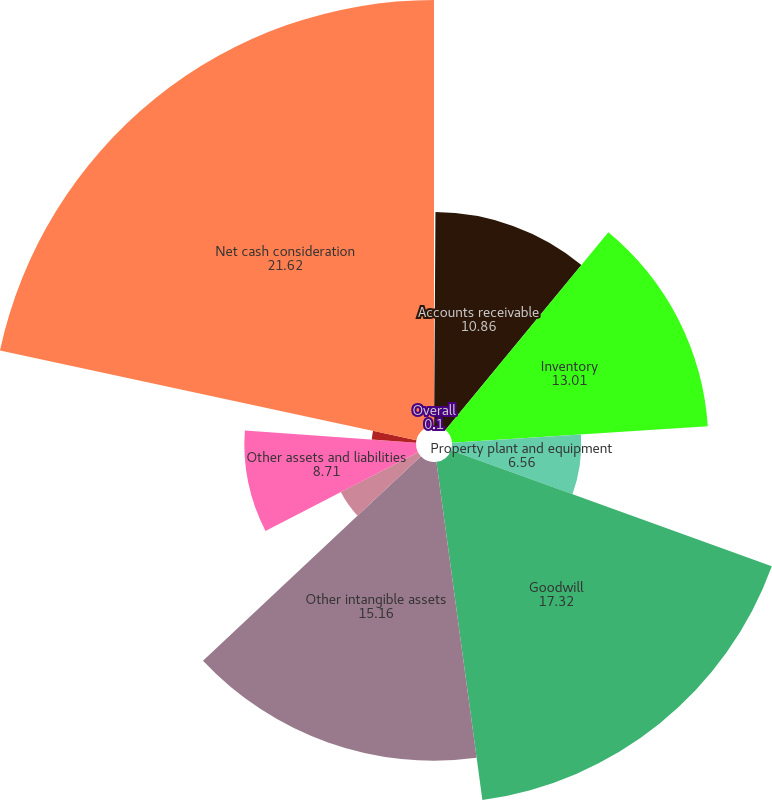Convert chart to OTSL. <chart><loc_0><loc_0><loc_500><loc_500><pie_chart><fcel>Overall<fcel>Accounts receivable<fcel>Inventory<fcel>Property plant and equipment<fcel>Goodwill<fcel>Other intangible assets<fcel>Accounts payable<fcel>Other assets and liabilities<fcel>Assumed debt<fcel>Net cash consideration<nl><fcel>0.1%<fcel>10.86%<fcel>13.01%<fcel>6.56%<fcel>17.32%<fcel>15.16%<fcel>4.41%<fcel>8.71%<fcel>2.25%<fcel>21.62%<nl></chart> 